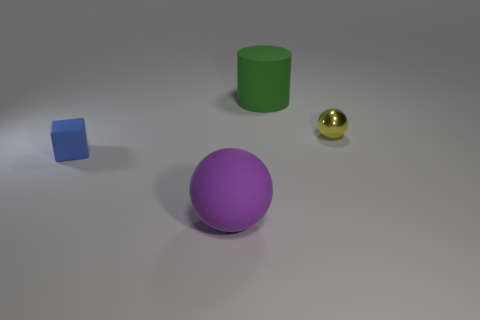What size is the blue block that is the same material as the large purple ball?
Offer a very short reply. Small. There is a object in front of the small blue object in front of the small object that is on the right side of the big purple rubber thing; how big is it?
Ensure brevity in your answer.  Large. What color is the ball right of the large matte cylinder?
Provide a short and direct response. Yellow. Are there more green things right of the large purple thing than shiny spheres?
Offer a very short reply. No. Does the small thing in front of the metal thing have the same shape as the shiny thing?
Provide a short and direct response. No. What number of purple objects are matte balls or metallic objects?
Offer a very short reply. 1. Is the number of big green rubber spheres greater than the number of green matte objects?
Give a very brief answer. No. The rubber object that is the same size as the purple rubber sphere is what color?
Offer a terse response. Green. How many cylinders are small red matte objects or small objects?
Keep it short and to the point. 0. Do the large purple rubber object and the object that is behind the small metallic thing have the same shape?
Your response must be concise. No. 